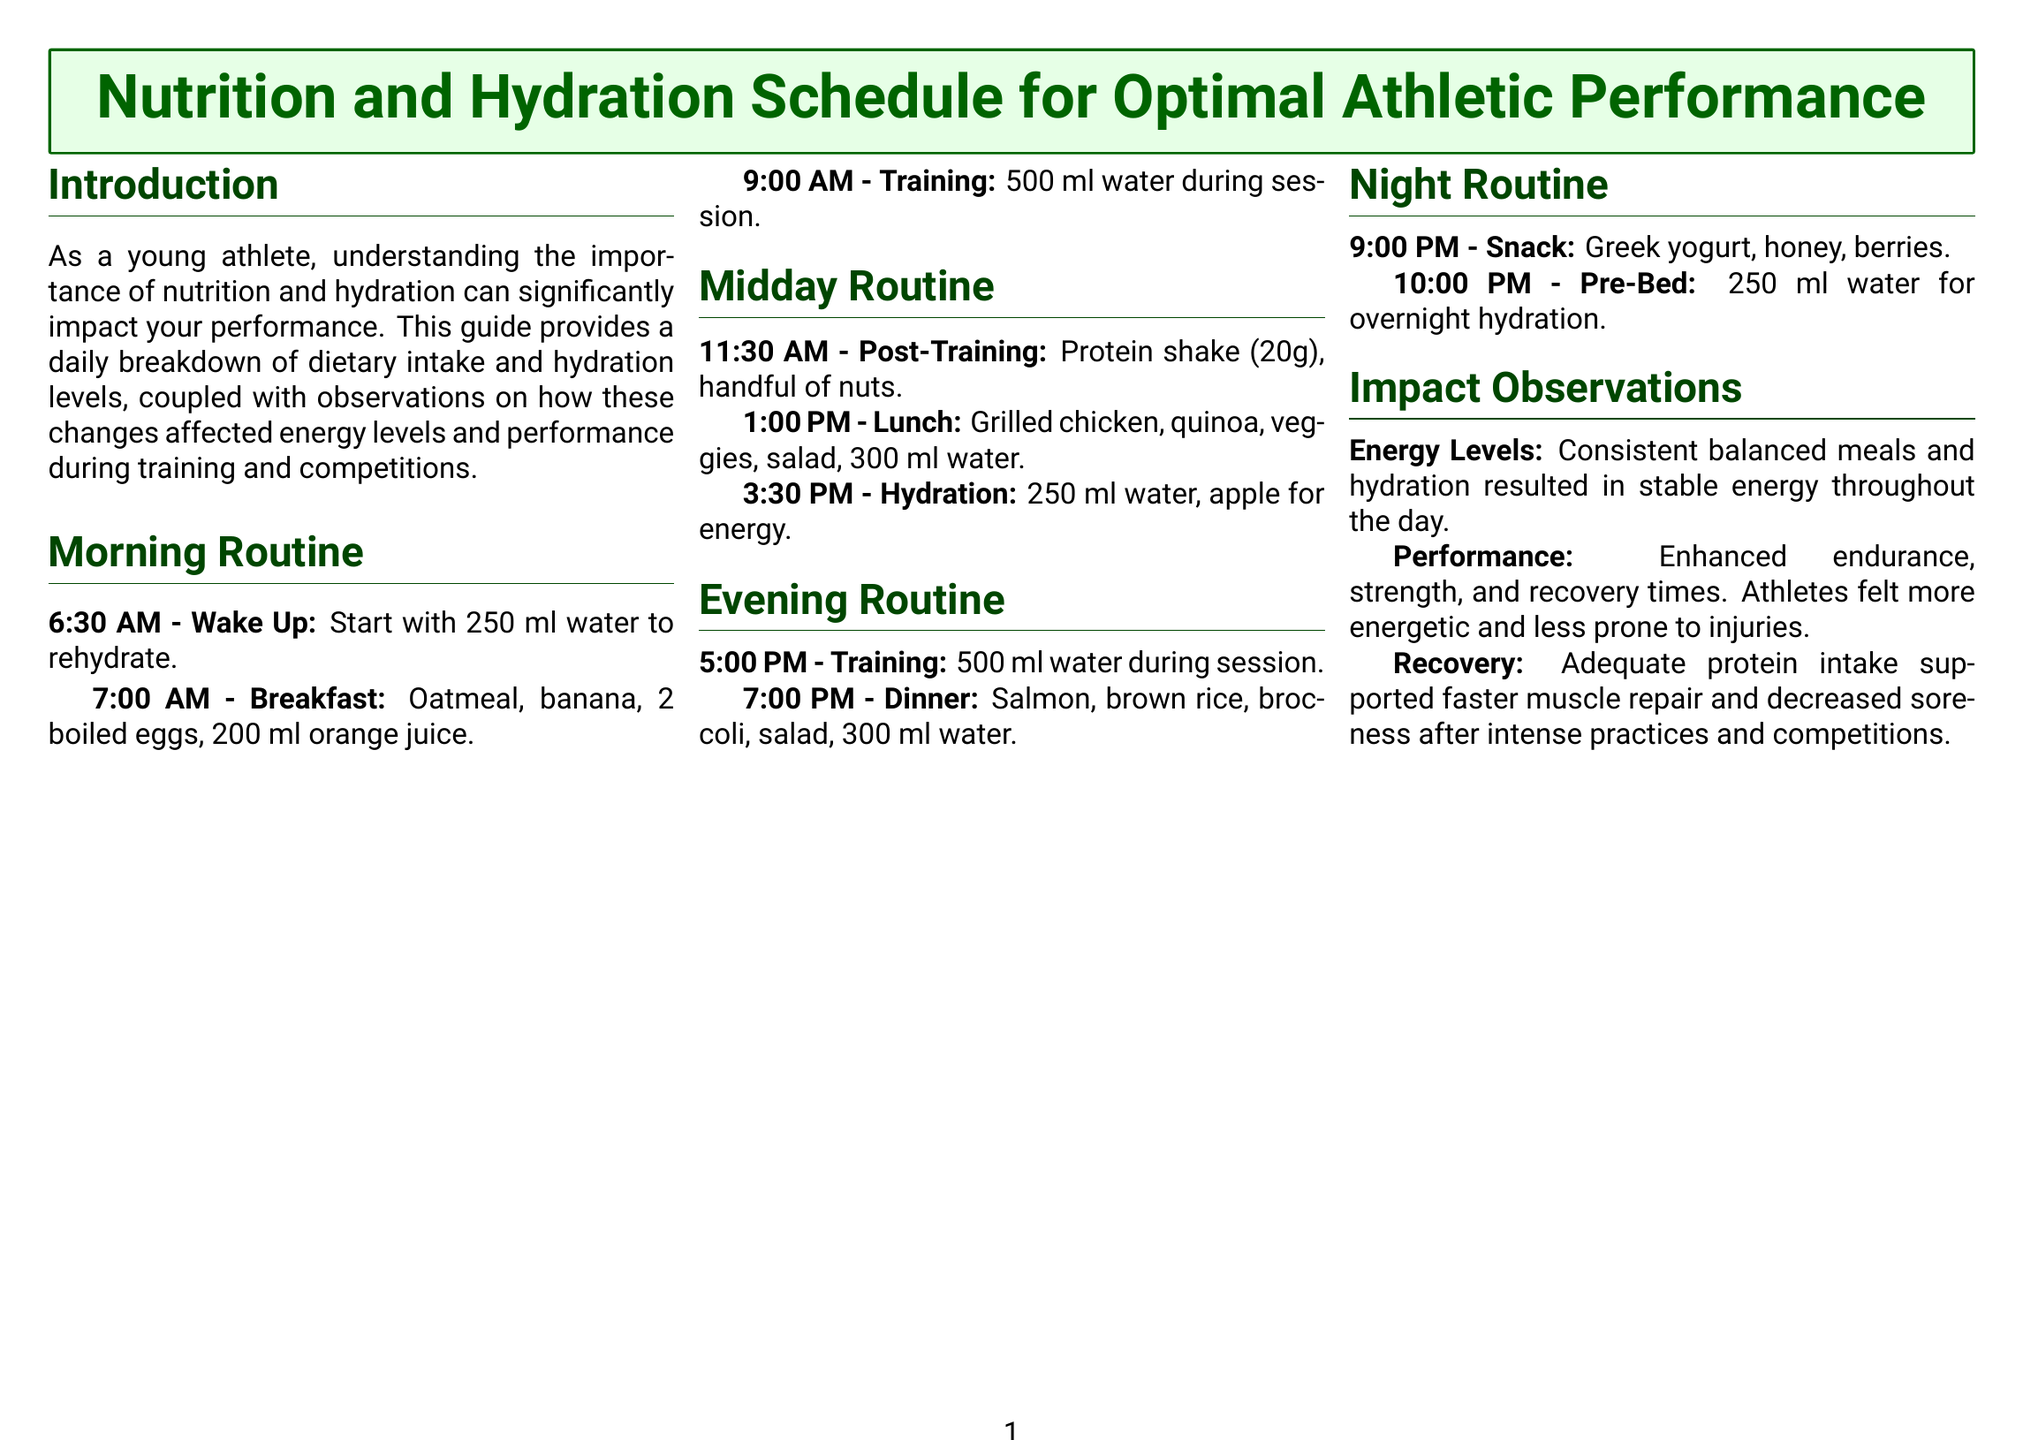what time do you have breakfast? Breakfast is scheduled for 7:00 AM.
Answer: 7:00 AM how much water is consumed during the morning training session? During the morning training session at 9:00 AM, 500 ml of water is consumed.
Answer: 500 ml what is included in the lunch? Lunch consists of grilled chicken, quinoa, veggies, salad, and 300 ml water.
Answer: Grilled chicken, quinoa, veggies, salad, 300 ml water what type of snack is eaten at night? The night snack is Greek yogurt, honey, and berries.
Answer: Greek yogurt, honey, berries how much water is consumed at bedtime? Pre-bed hydration includes 250 ml of water.
Answer: 250 ml how does adequate protein intake affect recovery? Adequate protein intake supports faster muscle repair and decreased soreness.
Answer: Faster muscle repair, decreased soreness what were athletes' feelings after consistent meals and hydration? Athletes felt more energetic and less prone to injuries.
Answer: More energetic, less prone to injuries what time is the post-training snack consumed? The post-training snack is consumed at 11:30 AM.
Answer: 11:30 AM 